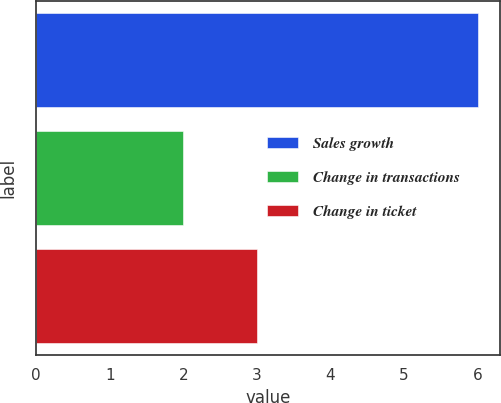Convert chart to OTSL. <chart><loc_0><loc_0><loc_500><loc_500><bar_chart><fcel>Sales growth<fcel>Change in transactions<fcel>Change in ticket<nl><fcel>6<fcel>2<fcel>3<nl></chart> 